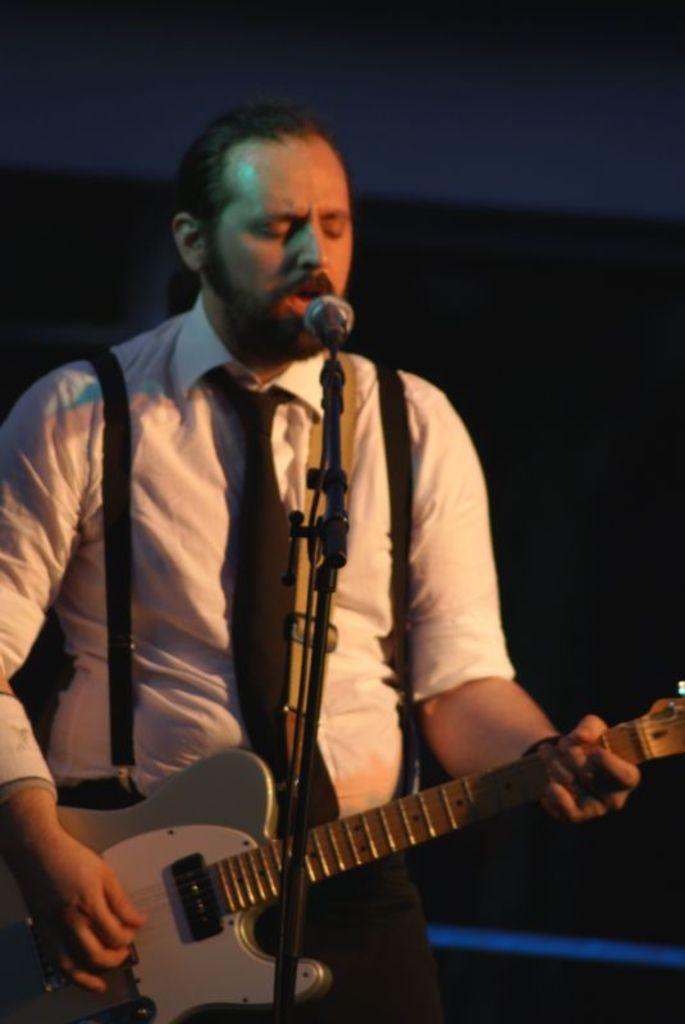How would you summarize this image in a sentence or two? A man is singing while playing guitar. He has a mic in front of him. he wears a white shirt and tie. 